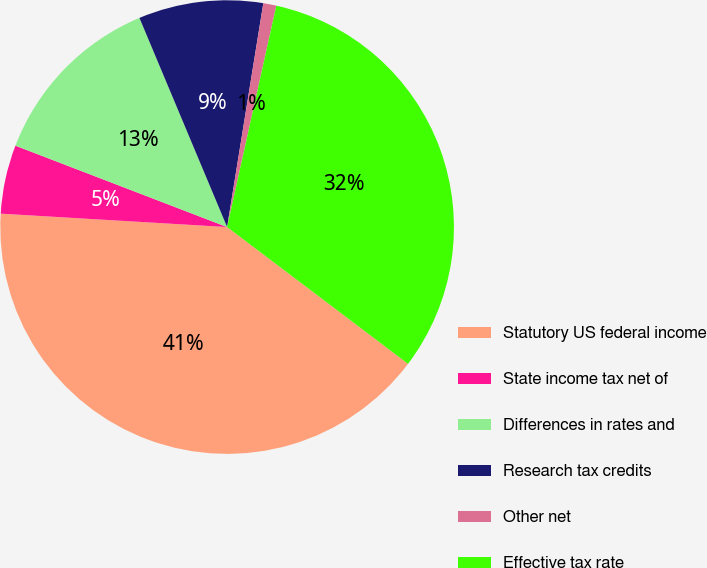<chart> <loc_0><loc_0><loc_500><loc_500><pie_chart><fcel>Statutory US federal income<fcel>State income tax net of<fcel>Differences in rates and<fcel>Research tax credits<fcel>Other net<fcel>Effective tax rate<nl><fcel>40.64%<fcel>4.9%<fcel>12.84%<fcel>8.87%<fcel>0.93%<fcel>31.82%<nl></chart> 